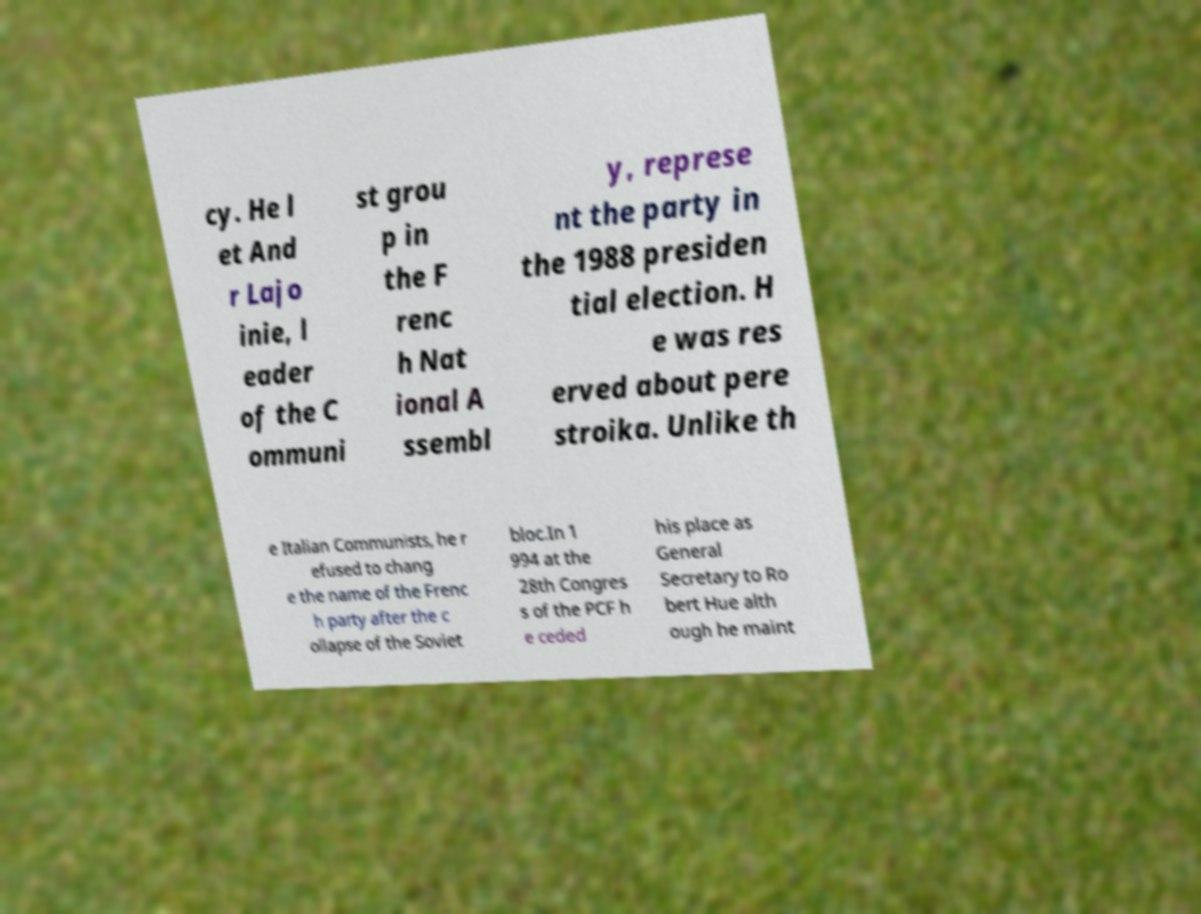Please identify and transcribe the text found in this image. cy. He l et And r Lajo inie, l eader of the C ommuni st grou p in the F renc h Nat ional A ssembl y, represe nt the party in the 1988 presiden tial election. H e was res erved about pere stroika. Unlike th e Italian Communists, he r efused to chang e the name of the Frenc h party after the c ollapse of the Soviet bloc.In 1 994 at the 28th Congres s of the PCF h e ceded his place as General Secretary to Ro bert Hue alth ough he maint 